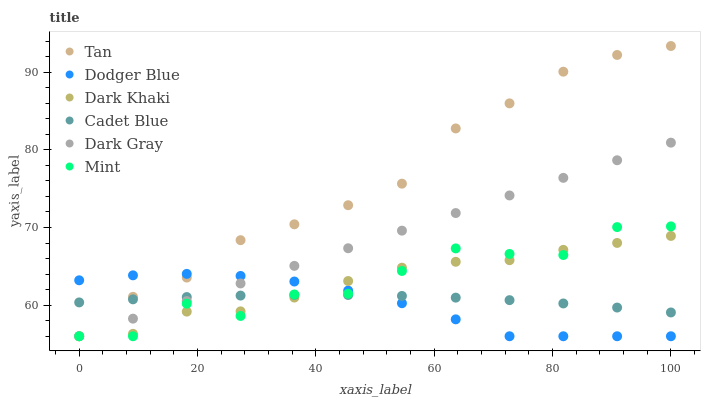Does Dodger Blue have the minimum area under the curve?
Answer yes or no. Yes. Does Tan have the maximum area under the curve?
Answer yes or no. Yes. Does Cadet Blue have the minimum area under the curve?
Answer yes or no. No. Does Cadet Blue have the maximum area under the curve?
Answer yes or no. No. Is Dark Gray the smoothest?
Answer yes or no. Yes. Is Mint the roughest?
Answer yes or no. Yes. Is Cadet Blue the smoothest?
Answer yes or no. No. Is Cadet Blue the roughest?
Answer yes or no. No. Does Dark Gray have the lowest value?
Answer yes or no. Yes. Does Cadet Blue have the lowest value?
Answer yes or no. No. Does Tan have the highest value?
Answer yes or no. Yes. Does Dark Khaki have the highest value?
Answer yes or no. No. Does Mint intersect Dodger Blue?
Answer yes or no. Yes. Is Mint less than Dodger Blue?
Answer yes or no. No. Is Mint greater than Dodger Blue?
Answer yes or no. No. 